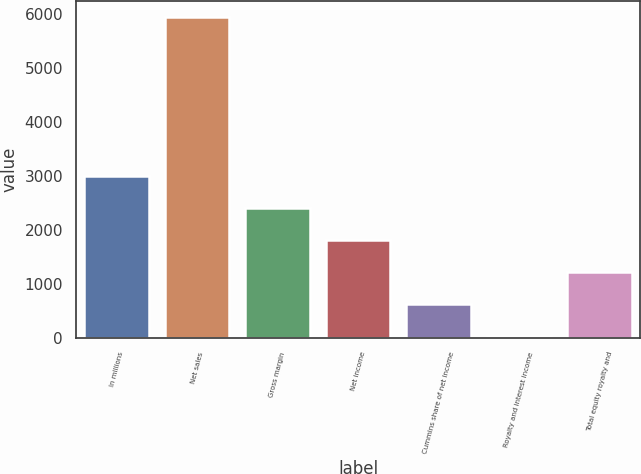<chart> <loc_0><loc_0><loc_500><loc_500><bar_chart><fcel>In millions<fcel>Net sales<fcel>Gross margin<fcel>Net income<fcel>Cummins share of net income<fcel>Royalty and interest income<fcel>Total equity royalty and<nl><fcel>2994<fcel>5946<fcel>2403.6<fcel>1813.2<fcel>632.4<fcel>42<fcel>1222.8<nl></chart> 